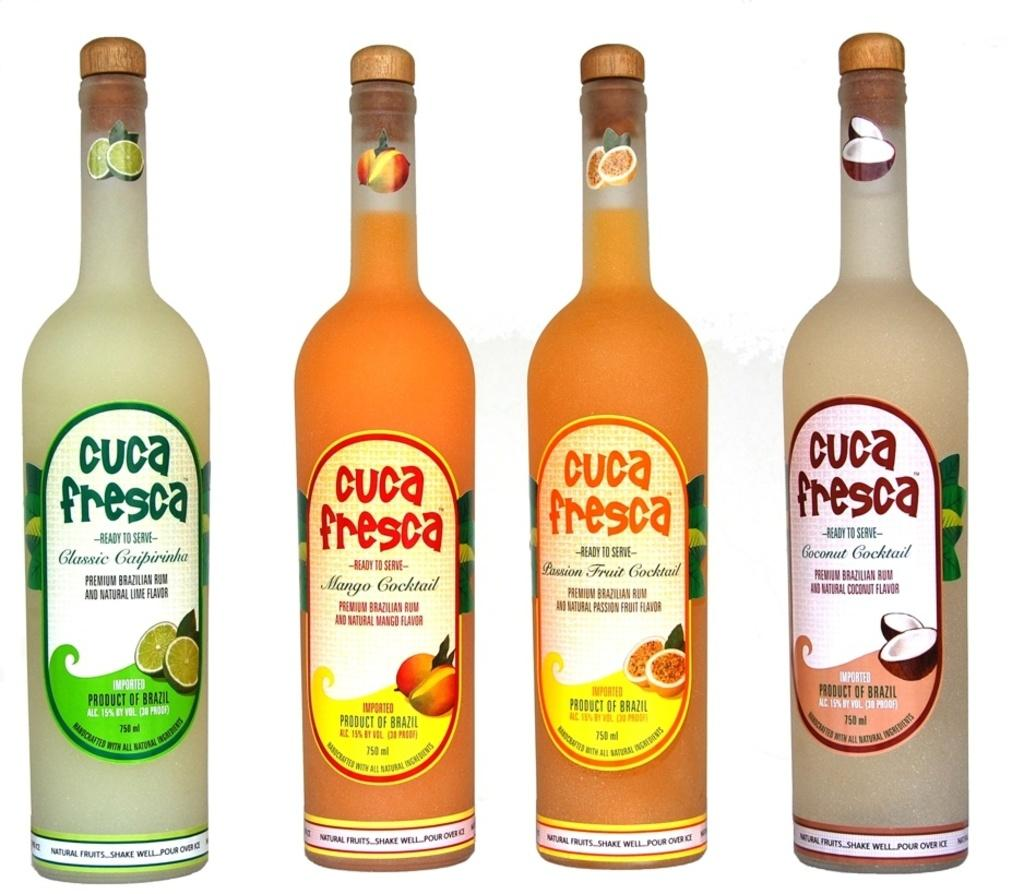<image>
Render a clear and concise summary of the photo. Bottles of a drink called Cuca Fresca sitting by each other. 